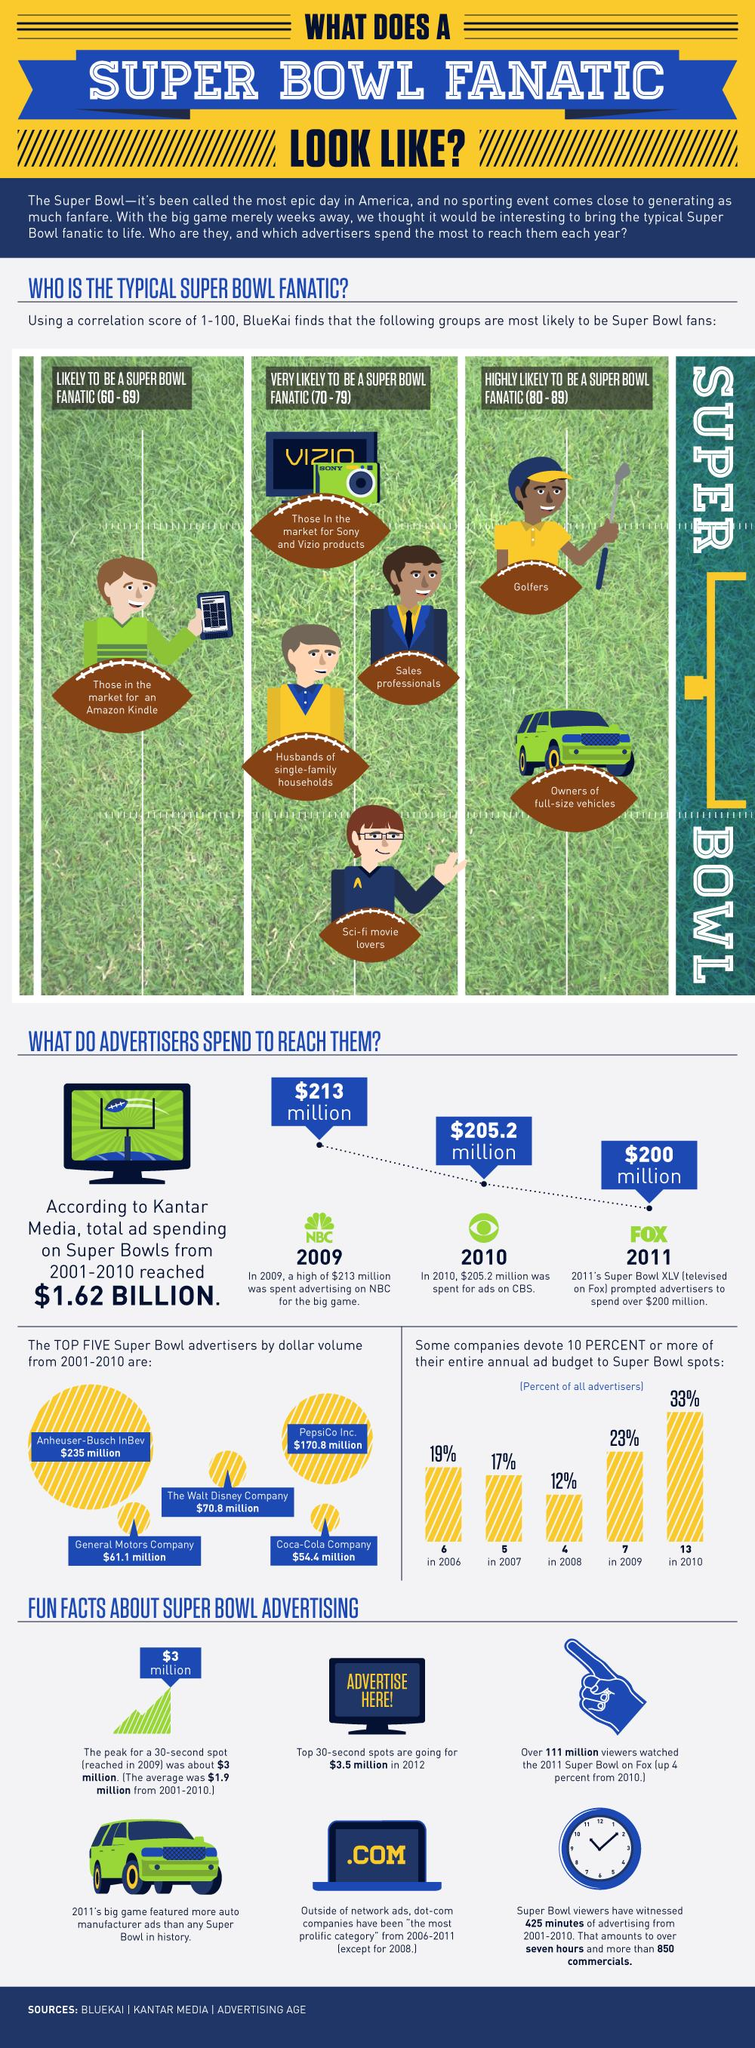Highlight a few significant elements in this photo. According to the infographic, in 2011, more vehicle manufacturer ads were featured than in any Super Bowl in history. With a high likelihood, a golfer is likely to be a super bowl fanatic. The owner of a full-size vehicle is the most likely to be a super bowl fanatic. 